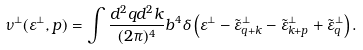<formula> <loc_0><loc_0><loc_500><loc_500>\nu ^ { \perp } ( \varepsilon ^ { \perp } , { p } ) = \int \frac { d ^ { 2 } { q } d ^ { 2 } { k } } { ( 2 \pi ) ^ { 4 } } b ^ { 4 } \delta \left ( \varepsilon ^ { \perp } - \tilde { \varepsilon } ^ { \perp } _ { { q } + { k } } - \tilde { \varepsilon } ^ { \perp } _ { { k } + { p } } + \tilde { \varepsilon } ^ { \perp } _ { q } \right ) .</formula> 